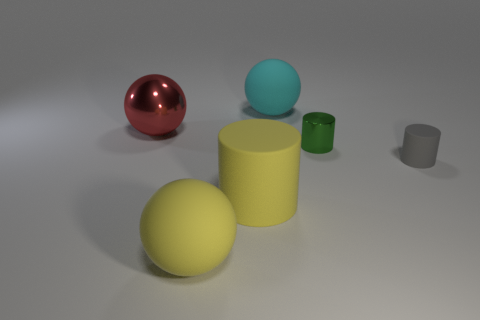Subtract all tiny cylinders. How many cylinders are left? 1 Subtract all gray cylinders. How many cylinders are left? 2 Add 1 big rubber cylinders. How many objects exist? 7 Subtract 1 balls. How many balls are left? 2 Subtract all brown blocks. How many purple cylinders are left? 0 Subtract all small brown metal spheres. Subtract all large yellow matte objects. How many objects are left? 4 Add 5 tiny green things. How many tiny green things are left? 6 Add 6 big objects. How many big objects exist? 10 Subtract 0 blue balls. How many objects are left? 6 Subtract all red cylinders. Subtract all gray cubes. How many cylinders are left? 3 